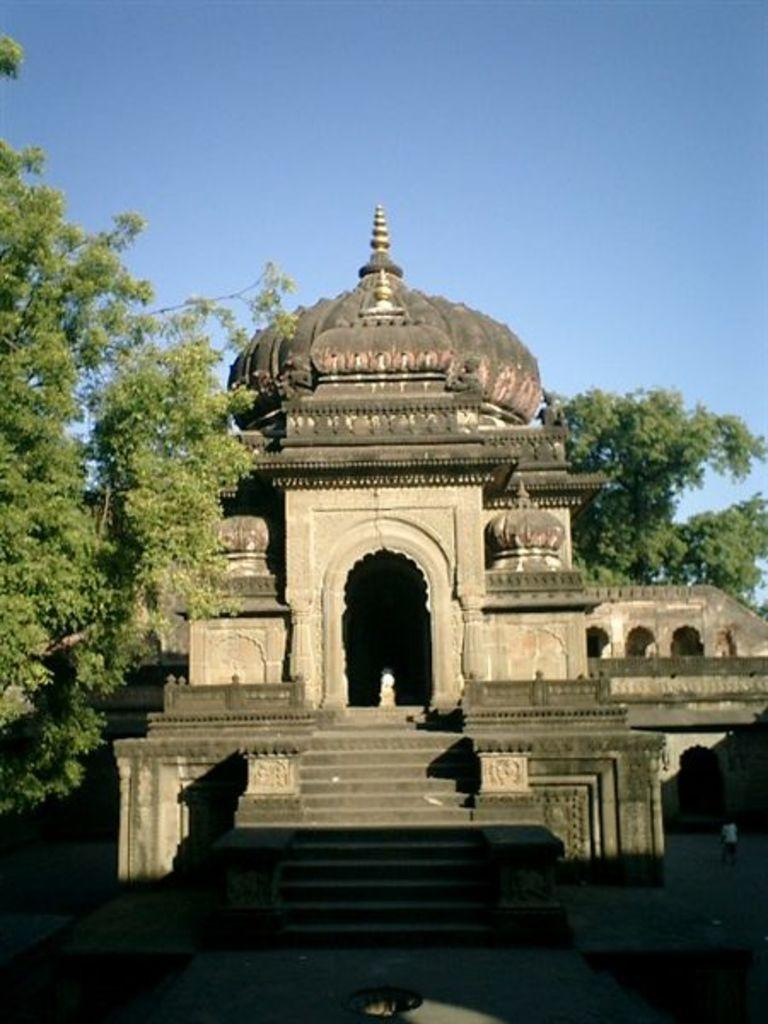What is the main structure in the image? There is a monument in the image. What type of natural elements can be seen in the image? There are trees in the image. How would you describe the sky in the image? The sky is clear and blue in the image. Where is the daughter sitting by the lake in the image? There is no daughter or lake present in the image. 